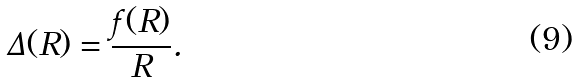Convert formula to latex. <formula><loc_0><loc_0><loc_500><loc_500>\Delta ( R ) = \frac { f ( R ) } { R } .</formula> 